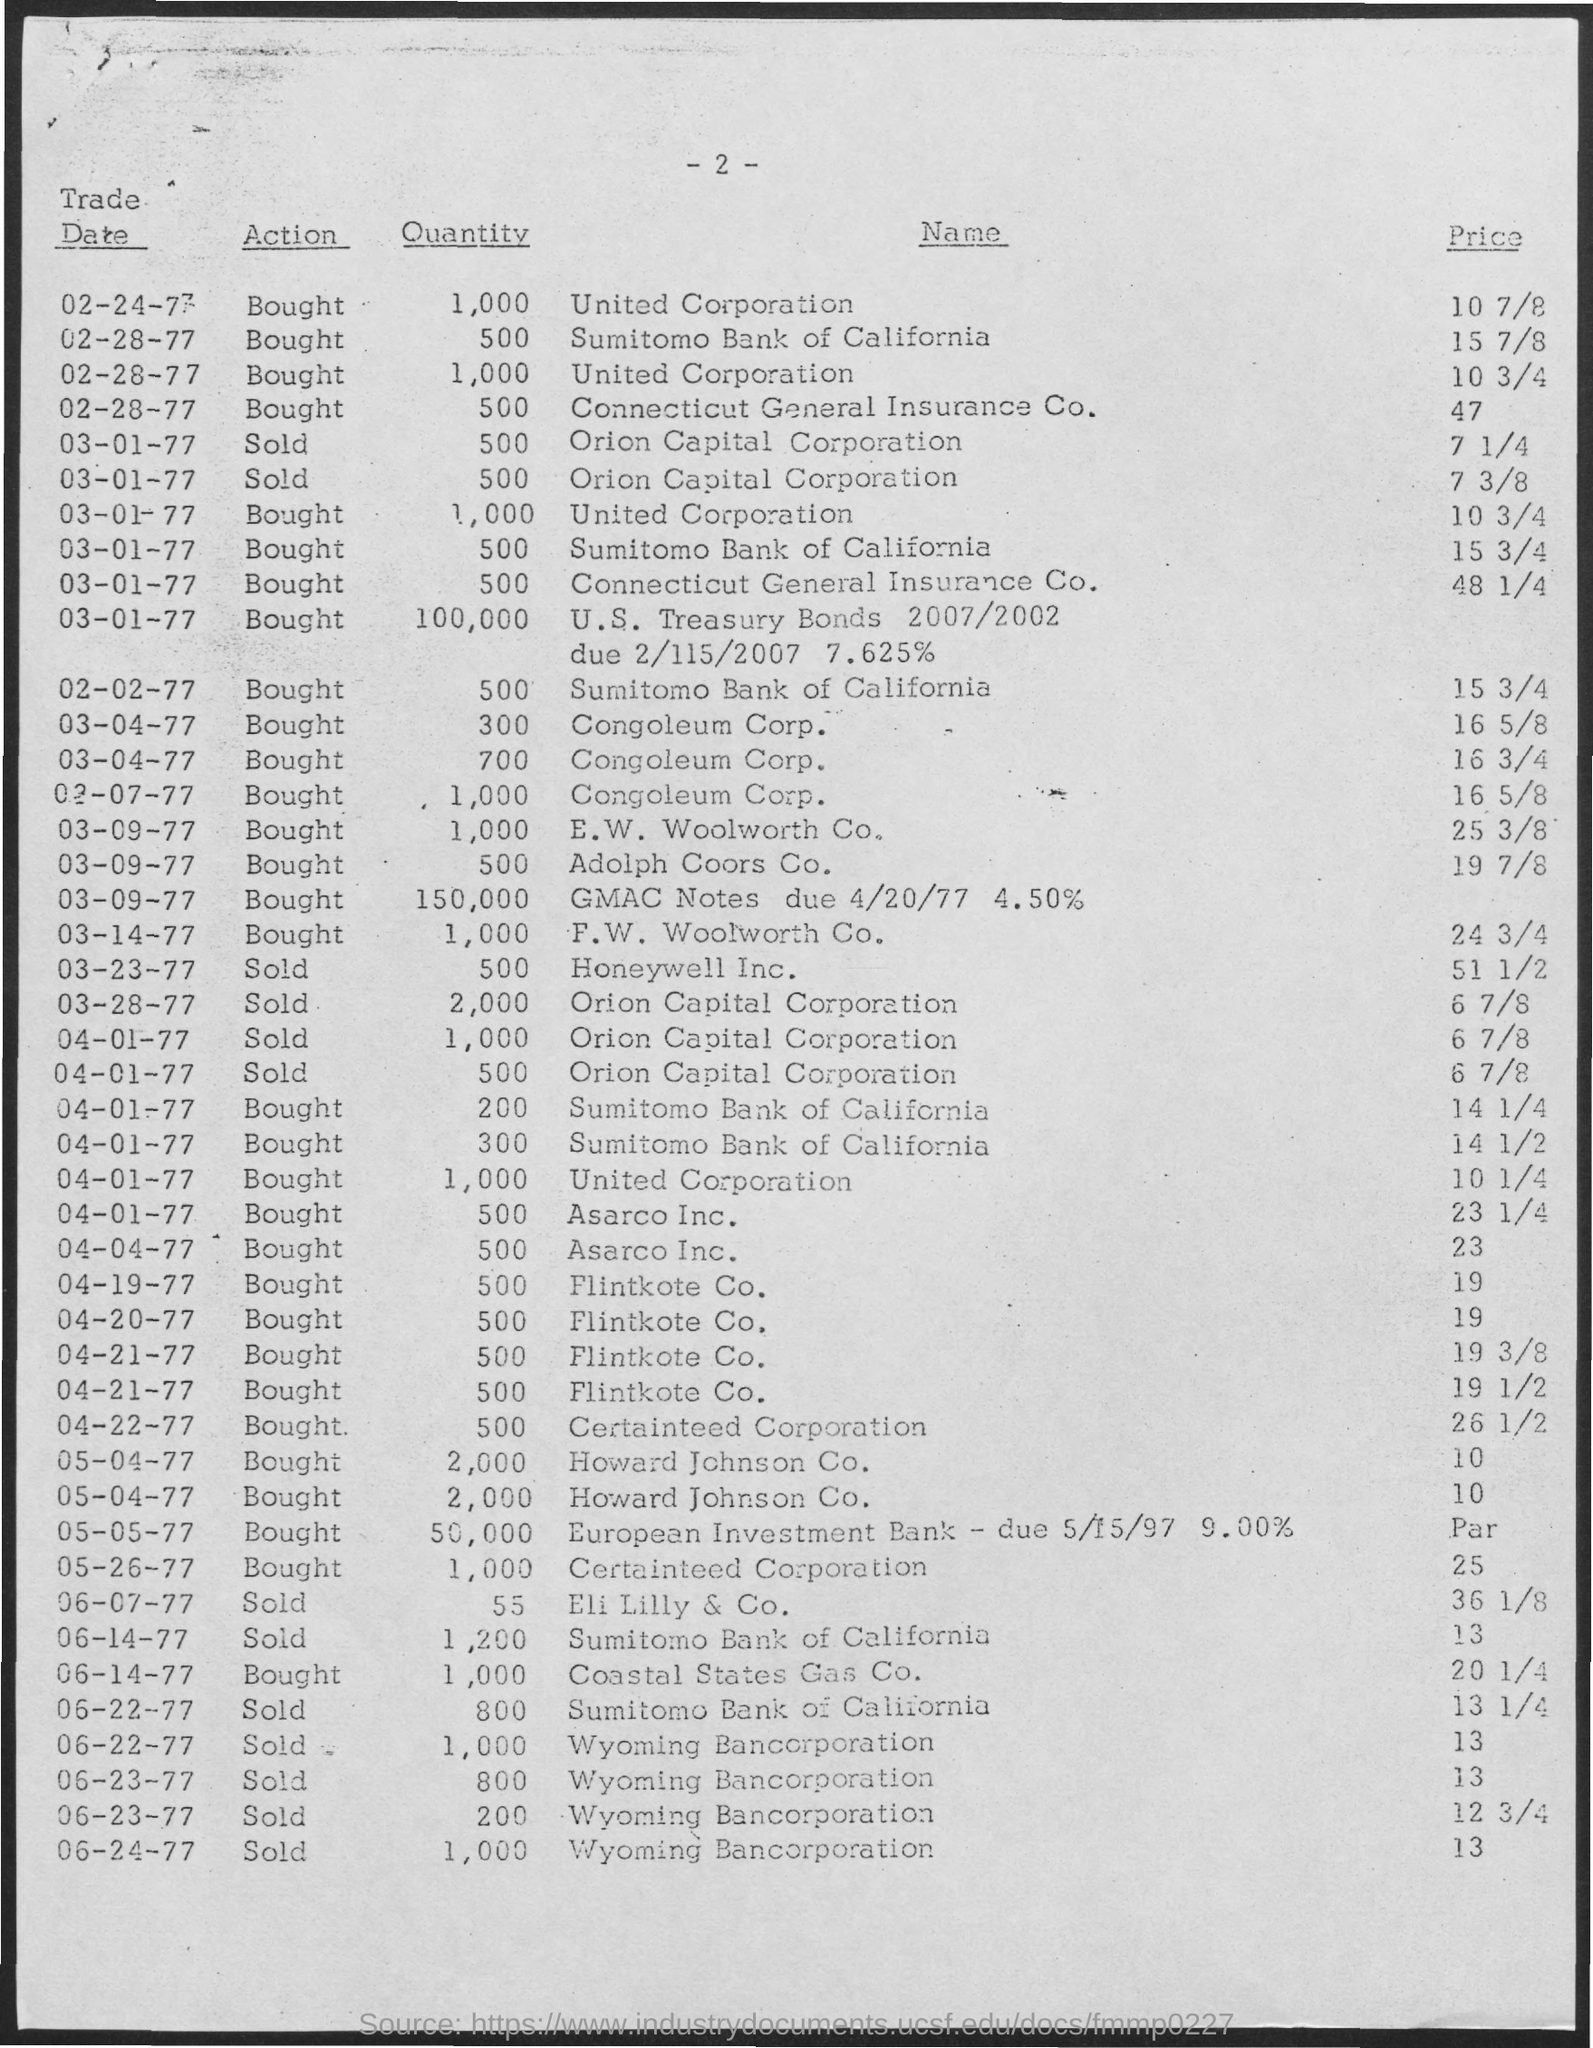List a handful of essential elements in this visual. The quantity for the trade date of March 14th, 1977 was 1,000. On April 22nd, 1977, the quantity for trade was 500. On April 20th, 1977, there was a trade with a quantity of 500... On April 4th, 1977, the quantity being traded was 500... The quantity for the trade date of March 28th, 1977, is 2,000. 